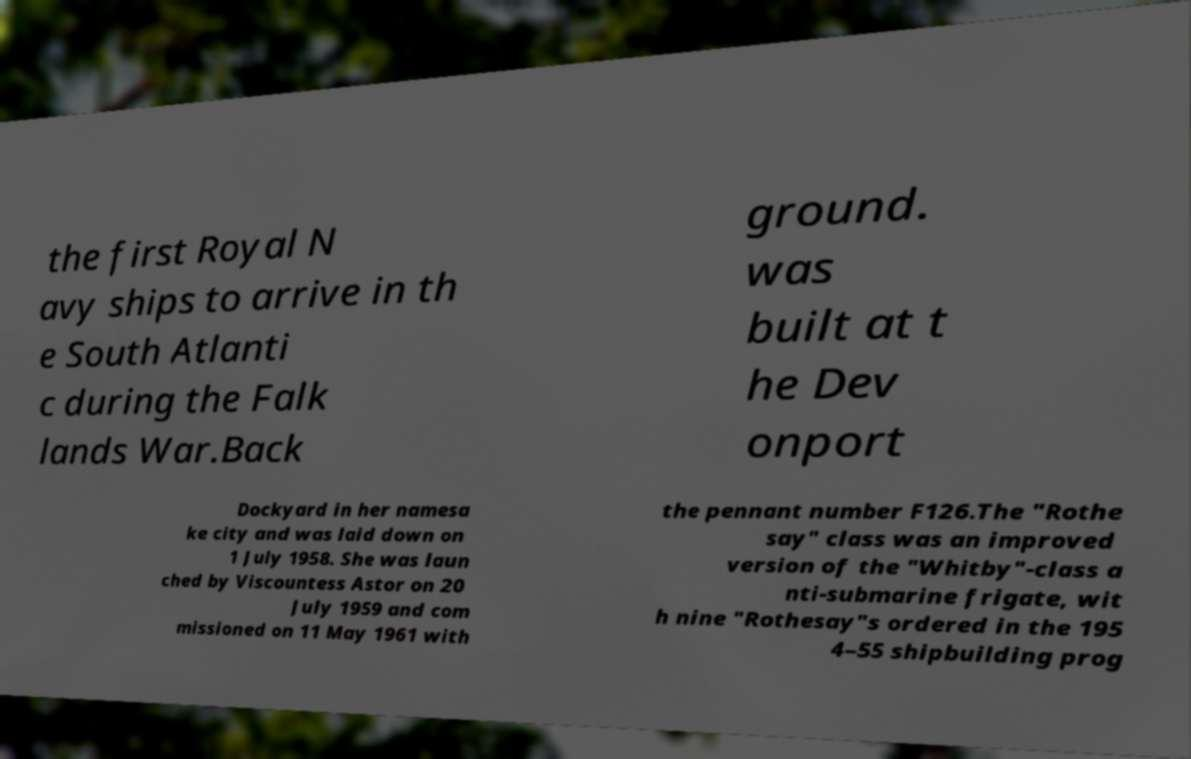Could you extract and type out the text from this image? the first Royal N avy ships to arrive in th e South Atlanti c during the Falk lands War.Back ground. was built at t he Dev onport Dockyard in her namesa ke city and was laid down on 1 July 1958. She was laun ched by Viscountess Astor on 20 July 1959 and com missioned on 11 May 1961 with the pennant number F126.The "Rothe say" class was an improved version of the "Whitby"-class a nti-submarine frigate, wit h nine "Rothesay"s ordered in the 195 4–55 shipbuilding prog 